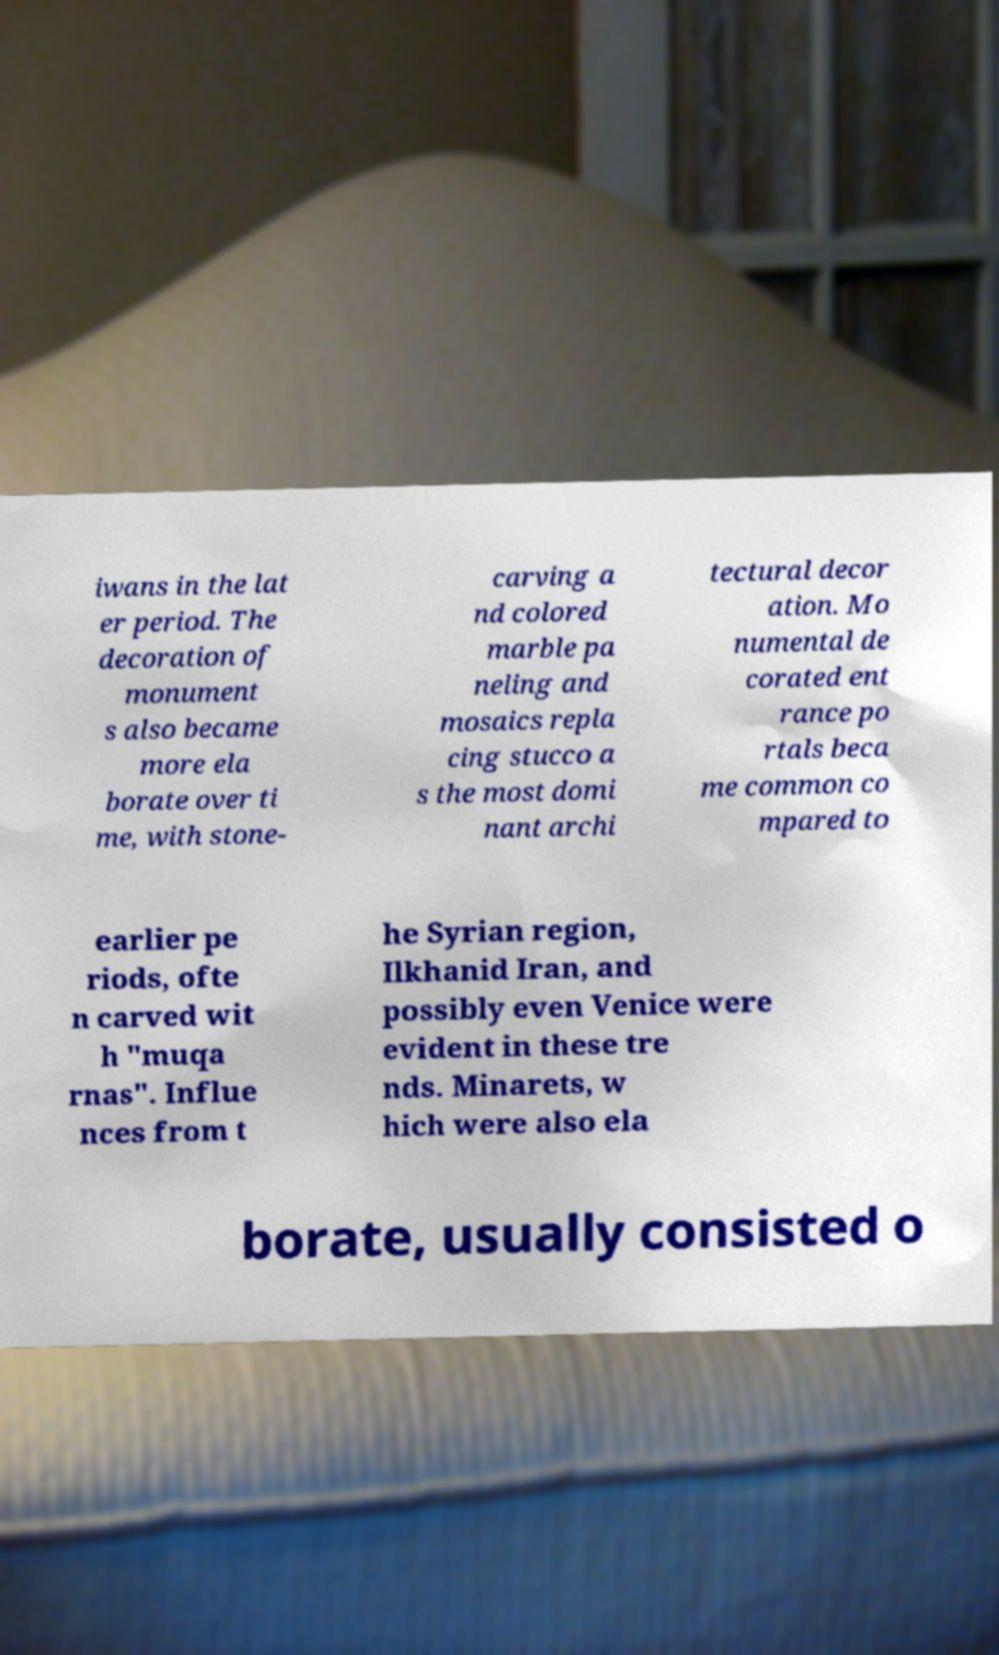Can you read and provide the text displayed in the image?This photo seems to have some interesting text. Can you extract and type it out for me? iwans in the lat er period. The decoration of monument s also became more ela borate over ti me, with stone- carving a nd colored marble pa neling and mosaics repla cing stucco a s the most domi nant archi tectural decor ation. Mo numental de corated ent rance po rtals beca me common co mpared to earlier pe riods, ofte n carved wit h "muqa rnas". Influe nces from t he Syrian region, Ilkhanid Iran, and possibly even Venice were evident in these tre nds. Minarets, w hich were also ela borate, usually consisted o 